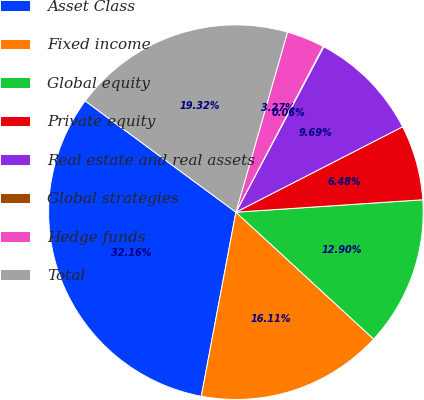Convert chart. <chart><loc_0><loc_0><loc_500><loc_500><pie_chart><fcel>Asset Class<fcel>Fixed income<fcel>Global equity<fcel>Private equity<fcel>Real estate and real assets<fcel>Global strategies<fcel>Hedge funds<fcel>Total<nl><fcel>32.16%<fcel>16.11%<fcel>12.9%<fcel>6.48%<fcel>9.69%<fcel>0.06%<fcel>3.27%<fcel>19.32%<nl></chart> 